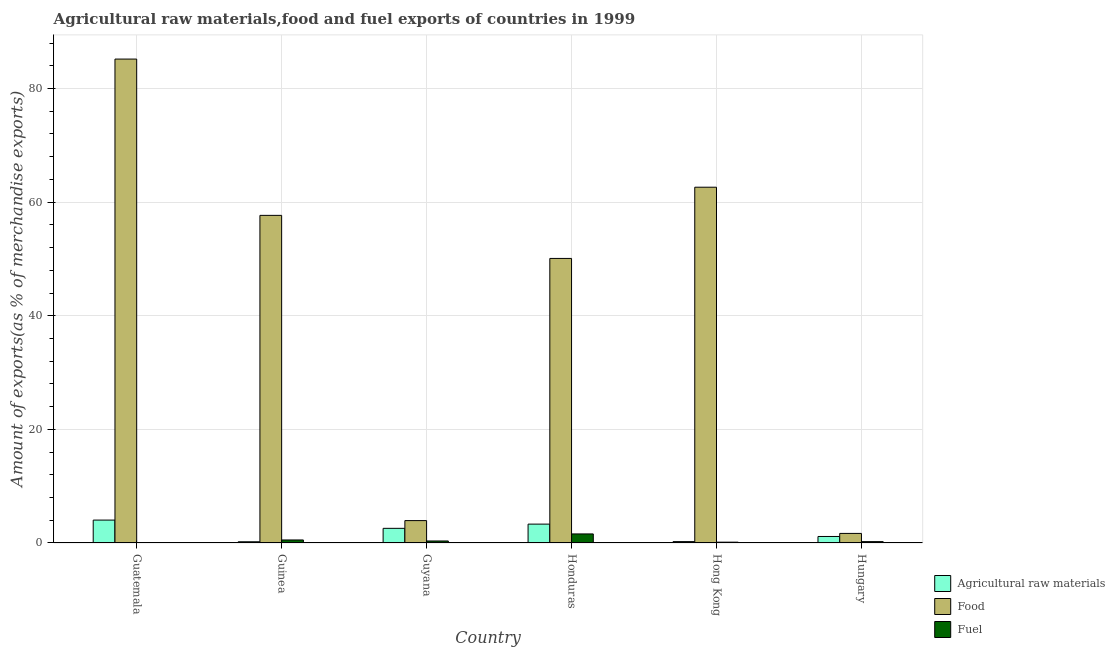How many different coloured bars are there?
Keep it short and to the point. 3. How many groups of bars are there?
Ensure brevity in your answer.  6. Are the number of bars per tick equal to the number of legend labels?
Give a very brief answer. Yes. How many bars are there on the 5th tick from the left?
Provide a short and direct response. 3. What is the label of the 2nd group of bars from the left?
Your response must be concise. Guinea. What is the percentage of fuel exports in Guinea?
Your answer should be compact. 0.53. Across all countries, what is the maximum percentage of fuel exports?
Offer a terse response. 1.59. Across all countries, what is the minimum percentage of food exports?
Your response must be concise. 1.69. In which country was the percentage of raw materials exports maximum?
Give a very brief answer. Guatemala. In which country was the percentage of fuel exports minimum?
Provide a succinct answer. Guatemala. What is the total percentage of food exports in the graph?
Your response must be concise. 261.2. What is the difference between the percentage of food exports in Guinea and that in Hungary?
Offer a terse response. 55.98. What is the difference between the percentage of raw materials exports in Honduras and the percentage of fuel exports in Guinea?
Offer a terse response. 2.79. What is the average percentage of food exports per country?
Your answer should be very brief. 43.53. What is the difference between the percentage of fuel exports and percentage of raw materials exports in Guatemala?
Your response must be concise. -4.03. In how many countries, is the percentage of fuel exports greater than 32 %?
Provide a succinct answer. 0. What is the ratio of the percentage of raw materials exports in Guyana to that in Honduras?
Offer a very short reply. 0.78. Is the difference between the percentage of raw materials exports in Guyana and Hong Kong greater than the difference between the percentage of fuel exports in Guyana and Hong Kong?
Give a very brief answer. Yes. What is the difference between the highest and the second highest percentage of food exports?
Keep it short and to the point. 22.56. What is the difference between the highest and the lowest percentage of raw materials exports?
Ensure brevity in your answer.  3.82. Is the sum of the percentage of fuel exports in Guatemala and Guinea greater than the maximum percentage of food exports across all countries?
Offer a terse response. No. What does the 1st bar from the left in Guinea represents?
Provide a short and direct response. Agricultural raw materials. What does the 1st bar from the right in Guatemala represents?
Keep it short and to the point. Fuel. How many bars are there?
Make the answer very short. 18. How many countries are there in the graph?
Keep it short and to the point. 6. Does the graph contain any zero values?
Your answer should be very brief. No. Where does the legend appear in the graph?
Offer a very short reply. Bottom right. How many legend labels are there?
Your response must be concise. 3. How are the legend labels stacked?
Keep it short and to the point. Vertical. What is the title of the graph?
Offer a terse response. Agricultural raw materials,food and fuel exports of countries in 1999. What is the label or title of the X-axis?
Provide a short and direct response. Country. What is the label or title of the Y-axis?
Make the answer very short. Amount of exports(as % of merchandise exports). What is the Amount of exports(as % of merchandise exports) of Agricultural raw materials in Guatemala?
Give a very brief answer. 4.03. What is the Amount of exports(as % of merchandise exports) of Food in Guatemala?
Provide a succinct answer. 85.18. What is the Amount of exports(as % of merchandise exports) in Fuel in Guatemala?
Keep it short and to the point. 0. What is the Amount of exports(as % of merchandise exports) in Agricultural raw materials in Guinea?
Offer a terse response. 0.22. What is the Amount of exports(as % of merchandise exports) of Food in Guinea?
Offer a terse response. 57.67. What is the Amount of exports(as % of merchandise exports) in Fuel in Guinea?
Make the answer very short. 0.53. What is the Amount of exports(as % of merchandise exports) in Agricultural raw materials in Guyana?
Make the answer very short. 2.58. What is the Amount of exports(as % of merchandise exports) in Food in Guyana?
Keep it short and to the point. 3.94. What is the Amount of exports(as % of merchandise exports) in Fuel in Guyana?
Make the answer very short. 0.35. What is the Amount of exports(as % of merchandise exports) of Agricultural raw materials in Honduras?
Provide a succinct answer. 3.32. What is the Amount of exports(as % of merchandise exports) of Food in Honduras?
Keep it short and to the point. 50.09. What is the Amount of exports(as % of merchandise exports) in Fuel in Honduras?
Ensure brevity in your answer.  1.59. What is the Amount of exports(as % of merchandise exports) in Agricultural raw materials in Hong Kong?
Give a very brief answer. 0.24. What is the Amount of exports(as % of merchandise exports) in Food in Hong Kong?
Provide a short and direct response. 62.63. What is the Amount of exports(as % of merchandise exports) of Fuel in Hong Kong?
Your answer should be compact. 0.15. What is the Amount of exports(as % of merchandise exports) in Agricultural raw materials in Hungary?
Provide a short and direct response. 1.15. What is the Amount of exports(as % of merchandise exports) of Food in Hungary?
Provide a succinct answer. 1.69. What is the Amount of exports(as % of merchandise exports) in Fuel in Hungary?
Ensure brevity in your answer.  0.24. Across all countries, what is the maximum Amount of exports(as % of merchandise exports) of Agricultural raw materials?
Provide a succinct answer. 4.03. Across all countries, what is the maximum Amount of exports(as % of merchandise exports) in Food?
Ensure brevity in your answer.  85.18. Across all countries, what is the maximum Amount of exports(as % of merchandise exports) in Fuel?
Provide a short and direct response. 1.59. Across all countries, what is the minimum Amount of exports(as % of merchandise exports) in Agricultural raw materials?
Provide a short and direct response. 0.22. Across all countries, what is the minimum Amount of exports(as % of merchandise exports) in Food?
Provide a succinct answer. 1.69. Across all countries, what is the minimum Amount of exports(as % of merchandise exports) of Fuel?
Offer a terse response. 0. What is the total Amount of exports(as % of merchandise exports) in Agricultural raw materials in the graph?
Your response must be concise. 11.54. What is the total Amount of exports(as % of merchandise exports) in Food in the graph?
Your response must be concise. 261.2. What is the total Amount of exports(as % of merchandise exports) in Fuel in the graph?
Give a very brief answer. 2.86. What is the difference between the Amount of exports(as % of merchandise exports) of Agricultural raw materials in Guatemala and that in Guinea?
Your answer should be compact. 3.82. What is the difference between the Amount of exports(as % of merchandise exports) in Food in Guatemala and that in Guinea?
Offer a terse response. 27.51. What is the difference between the Amount of exports(as % of merchandise exports) of Fuel in Guatemala and that in Guinea?
Your answer should be very brief. -0.53. What is the difference between the Amount of exports(as % of merchandise exports) in Agricultural raw materials in Guatemala and that in Guyana?
Your response must be concise. 1.45. What is the difference between the Amount of exports(as % of merchandise exports) in Food in Guatemala and that in Guyana?
Make the answer very short. 81.24. What is the difference between the Amount of exports(as % of merchandise exports) of Fuel in Guatemala and that in Guyana?
Your answer should be very brief. -0.35. What is the difference between the Amount of exports(as % of merchandise exports) in Agricultural raw materials in Guatemala and that in Honduras?
Provide a short and direct response. 0.71. What is the difference between the Amount of exports(as % of merchandise exports) in Food in Guatemala and that in Honduras?
Provide a succinct answer. 35.09. What is the difference between the Amount of exports(as % of merchandise exports) of Fuel in Guatemala and that in Honduras?
Offer a terse response. -1.59. What is the difference between the Amount of exports(as % of merchandise exports) in Agricultural raw materials in Guatemala and that in Hong Kong?
Your answer should be compact. 3.79. What is the difference between the Amount of exports(as % of merchandise exports) of Food in Guatemala and that in Hong Kong?
Your answer should be very brief. 22.56. What is the difference between the Amount of exports(as % of merchandise exports) in Fuel in Guatemala and that in Hong Kong?
Your response must be concise. -0.15. What is the difference between the Amount of exports(as % of merchandise exports) in Agricultural raw materials in Guatemala and that in Hungary?
Offer a very short reply. 2.89. What is the difference between the Amount of exports(as % of merchandise exports) in Food in Guatemala and that in Hungary?
Keep it short and to the point. 83.5. What is the difference between the Amount of exports(as % of merchandise exports) in Fuel in Guatemala and that in Hungary?
Offer a very short reply. -0.24. What is the difference between the Amount of exports(as % of merchandise exports) in Agricultural raw materials in Guinea and that in Guyana?
Offer a very short reply. -2.36. What is the difference between the Amount of exports(as % of merchandise exports) in Food in Guinea and that in Guyana?
Provide a succinct answer. 53.73. What is the difference between the Amount of exports(as % of merchandise exports) in Fuel in Guinea and that in Guyana?
Keep it short and to the point. 0.18. What is the difference between the Amount of exports(as % of merchandise exports) of Agricultural raw materials in Guinea and that in Honduras?
Keep it short and to the point. -3.11. What is the difference between the Amount of exports(as % of merchandise exports) in Food in Guinea and that in Honduras?
Make the answer very short. 7.58. What is the difference between the Amount of exports(as % of merchandise exports) of Fuel in Guinea and that in Honduras?
Ensure brevity in your answer.  -1.06. What is the difference between the Amount of exports(as % of merchandise exports) in Agricultural raw materials in Guinea and that in Hong Kong?
Offer a very short reply. -0.03. What is the difference between the Amount of exports(as % of merchandise exports) in Food in Guinea and that in Hong Kong?
Offer a very short reply. -4.96. What is the difference between the Amount of exports(as % of merchandise exports) of Fuel in Guinea and that in Hong Kong?
Offer a very short reply. 0.39. What is the difference between the Amount of exports(as % of merchandise exports) in Agricultural raw materials in Guinea and that in Hungary?
Make the answer very short. -0.93. What is the difference between the Amount of exports(as % of merchandise exports) in Food in Guinea and that in Hungary?
Your answer should be very brief. 55.98. What is the difference between the Amount of exports(as % of merchandise exports) in Fuel in Guinea and that in Hungary?
Your answer should be very brief. 0.29. What is the difference between the Amount of exports(as % of merchandise exports) of Agricultural raw materials in Guyana and that in Honduras?
Offer a very short reply. -0.74. What is the difference between the Amount of exports(as % of merchandise exports) in Food in Guyana and that in Honduras?
Your answer should be very brief. -46.15. What is the difference between the Amount of exports(as % of merchandise exports) of Fuel in Guyana and that in Honduras?
Make the answer very short. -1.24. What is the difference between the Amount of exports(as % of merchandise exports) of Agricultural raw materials in Guyana and that in Hong Kong?
Your answer should be compact. 2.34. What is the difference between the Amount of exports(as % of merchandise exports) in Food in Guyana and that in Hong Kong?
Offer a terse response. -58.69. What is the difference between the Amount of exports(as % of merchandise exports) in Fuel in Guyana and that in Hong Kong?
Your answer should be very brief. 0.21. What is the difference between the Amount of exports(as % of merchandise exports) in Agricultural raw materials in Guyana and that in Hungary?
Provide a succinct answer. 1.43. What is the difference between the Amount of exports(as % of merchandise exports) of Food in Guyana and that in Hungary?
Offer a terse response. 2.25. What is the difference between the Amount of exports(as % of merchandise exports) of Fuel in Guyana and that in Hungary?
Keep it short and to the point. 0.12. What is the difference between the Amount of exports(as % of merchandise exports) in Agricultural raw materials in Honduras and that in Hong Kong?
Your response must be concise. 3.08. What is the difference between the Amount of exports(as % of merchandise exports) of Food in Honduras and that in Hong Kong?
Offer a very short reply. -12.54. What is the difference between the Amount of exports(as % of merchandise exports) in Fuel in Honduras and that in Hong Kong?
Offer a terse response. 1.45. What is the difference between the Amount of exports(as % of merchandise exports) of Agricultural raw materials in Honduras and that in Hungary?
Keep it short and to the point. 2.18. What is the difference between the Amount of exports(as % of merchandise exports) of Food in Honduras and that in Hungary?
Your answer should be compact. 48.4. What is the difference between the Amount of exports(as % of merchandise exports) of Fuel in Honduras and that in Hungary?
Your answer should be very brief. 1.36. What is the difference between the Amount of exports(as % of merchandise exports) of Agricultural raw materials in Hong Kong and that in Hungary?
Ensure brevity in your answer.  -0.9. What is the difference between the Amount of exports(as % of merchandise exports) of Food in Hong Kong and that in Hungary?
Your response must be concise. 60.94. What is the difference between the Amount of exports(as % of merchandise exports) of Fuel in Hong Kong and that in Hungary?
Your response must be concise. -0.09. What is the difference between the Amount of exports(as % of merchandise exports) in Agricultural raw materials in Guatemala and the Amount of exports(as % of merchandise exports) in Food in Guinea?
Offer a very short reply. -53.64. What is the difference between the Amount of exports(as % of merchandise exports) of Agricultural raw materials in Guatemala and the Amount of exports(as % of merchandise exports) of Fuel in Guinea?
Your response must be concise. 3.5. What is the difference between the Amount of exports(as % of merchandise exports) in Food in Guatemala and the Amount of exports(as % of merchandise exports) in Fuel in Guinea?
Your response must be concise. 84.65. What is the difference between the Amount of exports(as % of merchandise exports) of Agricultural raw materials in Guatemala and the Amount of exports(as % of merchandise exports) of Food in Guyana?
Provide a short and direct response. 0.09. What is the difference between the Amount of exports(as % of merchandise exports) in Agricultural raw materials in Guatemala and the Amount of exports(as % of merchandise exports) in Fuel in Guyana?
Your answer should be compact. 3.68. What is the difference between the Amount of exports(as % of merchandise exports) of Food in Guatemala and the Amount of exports(as % of merchandise exports) of Fuel in Guyana?
Provide a succinct answer. 84.83. What is the difference between the Amount of exports(as % of merchandise exports) in Agricultural raw materials in Guatemala and the Amount of exports(as % of merchandise exports) in Food in Honduras?
Provide a succinct answer. -46.06. What is the difference between the Amount of exports(as % of merchandise exports) of Agricultural raw materials in Guatemala and the Amount of exports(as % of merchandise exports) of Fuel in Honduras?
Provide a short and direct response. 2.44. What is the difference between the Amount of exports(as % of merchandise exports) of Food in Guatemala and the Amount of exports(as % of merchandise exports) of Fuel in Honduras?
Your answer should be compact. 83.59. What is the difference between the Amount of exports(as % of merchandise exports) in Agricultural raw materials in Guatemala and the Amount of exports(as % of merchandise exports) in Food in Hong Kong?
Provide a succinct answer. -58.59. What is the difference between the Amount of exports(as % of merchandise exports) of Agricultural raw materials in Guatemala and the Amount of exports(as % of merchandise exports) of Fuel in Hong Kong?
Your response must be concise. 3.89. What is the difference between the Amount of exports(as % of merchandise exports) of Food in Guatemala and the Amount of exports(as % of merchandise exports) of Fuel in Hong Kong?
Offer a terse response. 85.04. What is the difference between the Amount of exports(as % of merchandise exports) in Agricultural raw materials in Guatemala and the Amount of exports(as % of merchandise exports) in Food in Hungary?
Offer a terse response. 2.35. What is the difference between the Amount of exports(as % of merchandise exports) in Agricultural raw materials in Guatemala and the Amount of exports(as % of merchandise exports) in Fuel in Hungary?
Provide a succinct answer. 3.79. What is the difference between the Amount of exports(as % of merchandise exports) of Food in Guatemala and the Amount of exports(as % of merchandise exports) of Fuel in Hungary?
Keep it short and to the point. 84.95. What is the difference between the Amount of exports(as % of merchandise exports) in Agricultural raw materials in Guinea and the Amount of exports(as % of merchandise exports) in Food in Guyana?
Keep it short and to the point. -3.72. What is the difference between the Amount of exports(as % of merchandise exports) in Agricultural raw materials in Guinea and the Amount of exports(as % of merchandise exports) in Fuel in Guyana?
Give a very brief answer. -0.14. What is the difference between the Amount of exports(as % of merchandise exports) of Food in Guinea and the Amount of exports(as % of merchandise exports) of Fuel in Guyana?
Provide a short and direct response. 57.32. What is the difference between the Amount of exports(as % of merchandise exports) in Agricultural raw materials in Guinea and the Amount of exports(as % of merchandise exports) in Food in Honduras?
Provide a short and direct response. -49.87. What is the difference between the Amount of exports(as % of merchandise exports) of Agricultural raw materials in Guinea and the Amount of exports(as % of merchandise exports) of Fuel in Honduras?
Provide a short and direct response. -1.38. What is the difference between the Amount of exports(as % of merchandise exports) in Food in Guinea and the Amount of exports(as % of merchandise exports) in Fuel in Honduras?
Give a very brief answer. 56.08. What is the difference between the Amount of exports(as % of merchandise exports) of Agricultural raw materials in Guinea and the Amount of exports(as % of merchandise exports) of Food in Hong Kong?
Offer a very short reply. -62.41. What is the difference between the Amount of exports(as % of merchandise exports) in Agricultural raw materials in Guinea and the Amount of exports(as % of merchandise exports) in Fuel in Hong Kong?
Give a very brief answer. 0.07. What is the difference between the Amount of exports(as % of merchandise exports) in Food in Guinea and the Amount of exports(as % of merchandise exports) in Fuel in Hong Kong?
Provide a succinct answer. 57.52. What is the difference between the Amount of exports(as % of merchandise exports) of Agricultural raw materials in Guinea and the Amount of exports(as % of merchandise exports) of Food in Hungary?
Provide a short and direct response. -1.47. What is the difference between the Amount of exports(as % of merchandise exports) of Agricultural raw materials in Guinea and the Amount of exports(as % of merchandise exports) of Fuel in Hungary?
Your response must be concise. -0.02. What is the difference between the Amount of exports(as % of merchandise exports) in Food in Guinea and the Amount of exports(as % of merchandise exports) in Fuel in Hungary?
Your answer should be very brief. 57.43. What is the difference between the Amount of exports(as % of merchandise exports) in Agricultural raw materials in Guyana and the Amount of exports(as % of merchandise exports) in Food in Honduras?
Your answer should be compact. -47.51. What is the difference between the Amount of exports(as % of merchandise exports) in Agricultural raw materials in Guyana and the Amount of exports(as % of merchandise exports) in Fuel in Honduras?
Your answer should be very brief. 0.99. What is the difference between the Amount of exports(as % of merchandise exports) in Food in Guyana and the Amount of exports(as % of merchandise exports) in Fuel in Honduras?
Your response must be concise. 2.34. What is the difference between the Amount of exports(as % of merchandise exports) of Agricultural raw materials in Guyana and the Amount of exports(as % of merchandise exports) of Food in Hong Kong?
Make the answer very short. -60.05. What is the difference between the Amount of exports(as % of merchandise exports) of Agricultural raw materials in Guyana and the Amount of exports(as % of merchandise exports) of Fuel in Hong Kong?
Your answer should be very brief. 2.44. What is the difference between the Amount of exports(as % of merchandise exports) in Food in Guyana and the Amount of exports(as % of merchandise exports) in Fuel in Hong Kong?
Ensure brevity in your answer.  3.79. What is the difference between the Amount of exports(as % of merchandise exports) in Agricultural raw materials in Guyana and the Amount of exports(as % of merchandise exports) in Food in Hungary?
Make the answer very short. 0.89. What is the difference between the Amount of exports(as % of merchandise exports) in Agricultural raw materials in Guyana and the Amount of exports(as % of merchandise exports) in Fuel in Hungary?
Give a very brief answer. 2.34. What is the difference between the Amount of exports(as % of merchandise exports) in Food in Guyana and the Amount of exports(as % of merchandise exports) in Fuel in Hungary?
Your answer should be very brief. 3.7. What is the difference between the Amount of exports(as % of merchandise exports) of Agricultural raw materials in Honduras and the Amount of exports(as % of merchandise exports) of Food in Hong Kong?
Provide a short and direct response. -59.3. What is the difference between the Amount of exports(as % of merchandise exports) in Agricultural raw materials in Honduras and the Amount of exports(as % of merchandise exports) in Fuel in Hong Kong?
Your answer should be compact. 3.18. What is the difference between the Amount of exports(as % of merchandise exports) in Food in Honduras and the Amount of exports(as % of merchandise exports) in Fuel in Hong Kong?
Offer a terse response. 49.94. What is the difference between the Amount of exports(as % of merchandise exports) of Agricultural raw materials in Honduras and the Amount of exports(as % of merchandise exports) of Food in Hungary?
Offer a terse response. 1.64. What is the difference between the Amount of exports(as % of merchandise exports) in Agricultural raw materials in Honduras and the Amount of exports(as % of merchandise exports) in Fuel in Hungary?
Offer a very short reply. 3.08. What is the difference between the Amount of exports(as % of merchandise exports) in Food in Honduras and the Amount of exports(as % of merchandise exports) in Fuel in Hungary?
Offer a terse response. 49.85. What is the difference between the Amount of exports(as % of merchandise exports) in Agricultural raw materials in Hong Kong and the Amount of exports(as % of merchandise exports) in Food in Hungary?
Offer a terse response. -1.44. What is the difference between the Amount of exports(as % of merchandise exports) of Agricultural raw materials in Hong Kong and the Amount of exports(as % of merchandise exports) of Fuel in Hungary?
Your answer should be very brief. 0. What is the difference between the Amount of exports(as % of merchandise exports) of Food in Hong Kong and the Amount of exports(as % of merchandise exports) of Fuel in Hungary?
Make the answer very short. 62.39. What is the average Amount of exports(as % of merchandise exports) of Agricultural raw materials per country?
Your answer should be compact. 1.92. What is the average Amount of exports(as % of merchandise exports) in Food per country?
Your response must be concise. 43.53. What is the average Amount of exports(as % of merchandise exports) of Fuel per country?
Provide a short and direct response. 0.48. What is the difference between the Amount of exports(as % of merchandise exports) in Agricultural raw materials and Amount of exports(as % of merchandise exports) in Food in Guatemala?
Your answer should be compact. -81.15. What is the difference between the Amount of exports(as % of merchandise exports) of Agricultural raw materials and Amount of exports(as % of merchandise exports) of Fuel in Guatemala?
Keep it short and to the point. 4.03. What is the difference between the Amount of exports(as % of merchandise exports) of Food and Amount of exports(as % of merchandise exports) of Fuel in Guatemala?
Provide a succinct answer. 85.18. What is the difference between the Amount of exports(as % of merchandise exports) of Agricultural raw materials and Amount of exports(as % of merchandise exports) of Food in Guinea?
Offer a terse response. -57.45. What is the difference between the Amount of exports(as % of merchandise exports) of Agricultural raw materials and Amount of exports(as % of merchandise exports) of Fuel in Guinea?
Your response must be concise. -0.31. What is the difference between the Amount of exports(as % of merchandise exports) of Food and Amount of exports(as % of merchandise exports) of Fuel in Guinea?
Make the answer very short. 57.14. What is the difference between the Amount of exports(as % of merchandise exports) of Agricultural raw materials and Amount of exports(as % of merchandise exports) of Food in Guyana?
Offer a terse response. -1.36. What is the difference between the Amount of exports(as % of merchandise exports) of Agricultural raw materials and Amount of exports(as % of merchandise exports) of Fuel in Guyana?
Your response must be concise. 2.23. What is the difference between the Amount of exports(as % of merchandise exports) in Food and Amount of exports(as % of merchandise exports) in Fuel in Guyana?
Keep it short and to the point. 3.59. What is the difference between the Amount of exports(as % of merchandise exports) in Agricultural raw materials and Amount of exports(as % of merchandise exports) in Food in Honduras?
Your answer should be very brief. -46.77. What is the difference between the Amount of exports(as % of merchandise exports) of Agricultural raw materials and Amount of exports(as % of merchandise exports) of Fuel in Honduras?
Provide a short and direct response. 1.73. What is the difference between the Amount of exports(as % of merchandise exports) of Food and Amount of exports(as % of merchandise exports) of Fuel in Honduras?
Offer a very short reply. 48.49. What is the difference between the Amount of exports(as % of merchandise exports) of Agricultural raw materials and Amount of exports(as % of merchandise exports) of Food in Hong Kong?
Ensure brevity in your answer.  -62.38. What is the difference between the Amount of exports(as % of merchandise exports) in Agricultural raw materials and Amount of exports(as % of merchandise exports) in Fuel in Hong Kong?
Keep it short and to the point. 0.1. What is the difference between the Amount of exports(as % of merchandise exports) in Food and Amount of exports(as % of merchandise exports) in Fuel in Hong Kong?
Your response must be concise. 62.48. What is the difference between the Amount of exports(as % of merchandise exports) of Agricultural raw materials and Amount of exports(as % of merchandise exports) of Food in Hungary?
Provide a succinct answer. -0.54. What is the difference between the Amount of exports(as % of merchandise exports) in Agricultural raw materials and Amount of exports(as % of merchandise exports) in Fuel in Hungary?
Your answer should be very brief. 0.91. What is the difference between the Amount of exports(as % of merchandise exports) in Food and Amount of exports(as % of merchandise exports) in Fuel in Hungary?
Offer a very short reply. 1.45. What is the ratio of the Amount of exports(as % of merchandise exports) of Agricultural raw materials in Guatemala to that in Guinea?
Your answer should be very brief. 18.55. What is the ratio of the Amount of exports(as % of merchandise exports) of Food in Guatemala to that in Guinea?
Provide a succinct answer. 1.48. What is the ratio of the Amount of exports(as % of merchandise exports) of Agricultural raw materials in Guatemala to that in Guyana?
Offer a very short reply. 1.56. What is the ratio of the Amount of exports(as % of merchandise exports) in Food in Guatemala to that in Guyana?
Give a very brief answer. 21.62. What is the ratio of the Amount of exports(as % of merchandise exports) of Agricultural raw materials in Guatemala to that in Honduras?
Your answer should be compact. 1.21. What is the ratio of the Amount of exports(as % of merchandise exports) in Food in Guatemala to that in Honduras?
Offer a terse response. 1.7. What is the ratio of the Amount of exports(as % of merchandise exports) of Agricultural raw materials in Guatemala to that in Hong Kong?
Provide a short and direct response. 16.6. What is the ratio of the Amount of exports(as % of merchandise exports) of Food in Guatemala to that in Hong Kong?
Ensure brevity in your answer.  1.36. What is the ratio of the Amount of exports(as % of merchandise exports) in Fuel in Guatemala to that in Hong Kong?
Make the answer very short. 0. What is the ratio of the Amount of exports(as % of merchandise exports) in Agricultural raw materials in Guatemala to that in Hungary?
Offer a terse response. 3.51. What is the ratio of the Amount of exports(as % of merchandise exports) in Food in Guatemala to that in Hungary?
Make the answer very short. 50.53. What is the ratio of the Amount of exports(as % of merchandise exports) in Agricultural raw materials in Guinea to that in Guyana?
Provide a succinct answer. 0.08. What is the ratio of the Amount of exports(as % of merchandise exports) of Food in Guinea to that in Guyana?
Give a very brief answer. 14.64. What is the ratio of the Amount of exports(as % of merchandise exports) in Fuel in Guinea to that in Guyana?
Give a very brief answer. 1.5. What is the ratio of the Amount of exports(as % of merchandise exports) of Agricultural raw materials in Guinea to that in Honduras?
Your response must be concise. 0.07. What is the ratio of the Amount of exports(as % of merchandise exports) of Food in Guinea to that in Honduras?
Make the answer very short. 1.15. What is the ratio of the Amount of exports(as % of merchandise exports) of Fuel in Guinea to that in Honduras?
Make the answer very short. 0.33. What is the ratio of the Amount of exports(as % of merchandise exports) in Agricultural raw materials in Guinea to that in Hong Kong?
Give a very brief answer. 0.89. What is the ratio of the Amount of exports(as % of merchandise exports) of Food in Guinea to that in Hong Kong?
Your answer should be compact. 0.92. What is the ratio of the Amount of exports(as % of merchandise exports) of Fuel in Guinea to that in Hong Kong?
Offer a terse response. 3.66. What is the ratio of the Amount of exports(as % of merchandise exports) in Agricultural raw materials in Guinea to that in Hungary?
Your response must be concise. 0.19. What is the ratio of the Amount of exports(as % of merchandise exports) of Food in Guinea to that in Hungary?
Provide a succinct answer. 34.21. What is the ratio of the Amount of exports(as % of merchandise exports) of Fuel in Guinea to that in Hungary?
Your answer should be very brief. 2.23. What is the ratio of the Amount of exports(as % of merchandise exports) in Agricultural raw materials in Guyana to that in Honduras?
Offer a very short reply. 0.78. What is the ratio of the Amount of exports(as % of merchandise exports) in Food in Guyana to that in Honduras?
Ensure brevity in your answer.  0.08. What is the ratio of the Amount of exports(as % of merchandise exports) in Fuel in Guyana to that in Honduras?
Your response must be concise. 0.22. What is the ratio of the Amount of exports(as % of merchandise exports) in Agricultural raw materials in Guyana to that in Hong Kong?
Your answer should be very brief. 10.62. What is the ratio of the Amount of exports(as % of merchandise exports) in Food in Guyana to that in Hong Kong?
Provide a succinct answer. 0.06. What is the ratio of the Amount of exports(as % of merchandise exports) in Fuel in Guyana to that in Hong Kong?
Offer a terse response. 2.43. What is the ratio of the Amount of exports(as % of merchandise exports) of Agricultural raw materials in Guyana to that in Hungary?
Provide a succinct answer. 2.25. What is the ratio of the Amount of exports(as % of merchandise exports) in Food in Guyana to that in Hungary?
Ensure brevity in your answer.  2.34. What is the ratio of the Amount of exports(as % of merchandise exports) in Fuel in Guyana to that in Hungary?
Provide a short and direct response. 1.48. What is the ratio of the Amount of exports(as % of merchandise exports) in Agricultural raw materials in Honduras to that in Hong Kong?
Your answer should be compact. 13.68. What is the ratio of the Amount of exports(as % of merchandise exports) of Food in Honduras to that in Hong Kong?
Your answer should be very brief. 0.8. What is the ratio of the Amount of exports(as % of merchandise exports) in Fuel in Honduras to that in Hong Kong?
Provide a short and direct response. 10.99. What is the ratio of the Amount of exports(as % of merchandise exports) of Agricultural raw materials in Honduras to that in Hungary?
Provide a short and direct response. 2.9. What is the ratio of the Amount of exports(as % of merchandise exports) in Food in Honduras to that in Hungary?
Give a very brief answer. 29.71. What is the ratio of the Amount of exports(as % of merchandise exports) in Fuel in Honduras to that in Hungary?
Make the answer very short. 6.7. What is the ratio of the Amount of exports(as % of merchandise exports) of Agricultural raw materials in Hong Kong to that in Hungary?
Provide a succinct answer. 0.21. What is the ratio of the Amount of exports(as % of merchandise exports) of Food in Hong Kong to that in Hungary?
Provide a short and direct response. 37.15. What is the ratio of the Amount of exports(as % of merchandise exports) of Fuel in Hong Kong to that in Hungary?
Your response must be concise. 0.61. What is the difference between the highest and the second highest Amount of exports(as % of merchandise exports) of Agricultural raw materials?
Make the answer very short. 0.71. What is the difference between the highest and the second highest Amount of exports(as % of merchandise exports) in Food?
Make the answer very short. 22.56. What is the difference between the highest and the second highest Amount of exports(as % of merchandise exports) of Fuel?
Give a very brief answer. 1.06. What is the difference between the highest and the lowest Amount of exports(as % of merchandise exports) of Agricultural raw materials?
Ensure brevity in your answer.  3.82. What is the difference between the highest and the lowest Amount of exports(as % of merchandise exports) in Food?
Your answer should be compact. 83.5. What is the difference between the highest and the lowest Amount of exports(as % of merchandise exports) in Fuel?
Give a very brief answer. 1.59. 